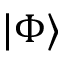<formula> <loc_0><loc_0><loc_500><loc_500>| \Phi \rangle</formula> 